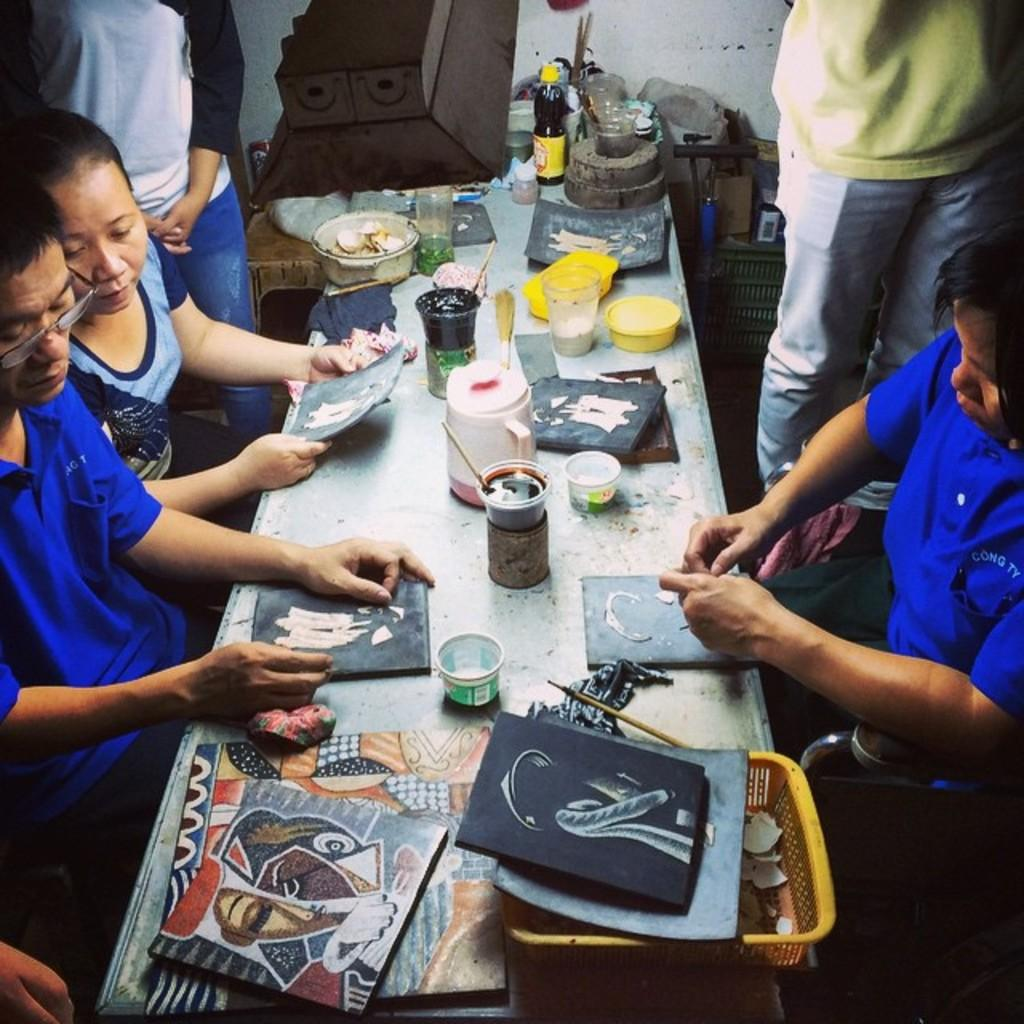What are the people in the image doing? The people in the image are painting. Are the people sitting or standing? There are people seated and standing in the image. What objects can be seen on the table in the image? There are cups, brushes, and a bottle on the table in the image. Can you see any trails left by the zephyr in the image? There is no mention of a zephyr or any trails in the image. The image features people painting and objects on a table. 